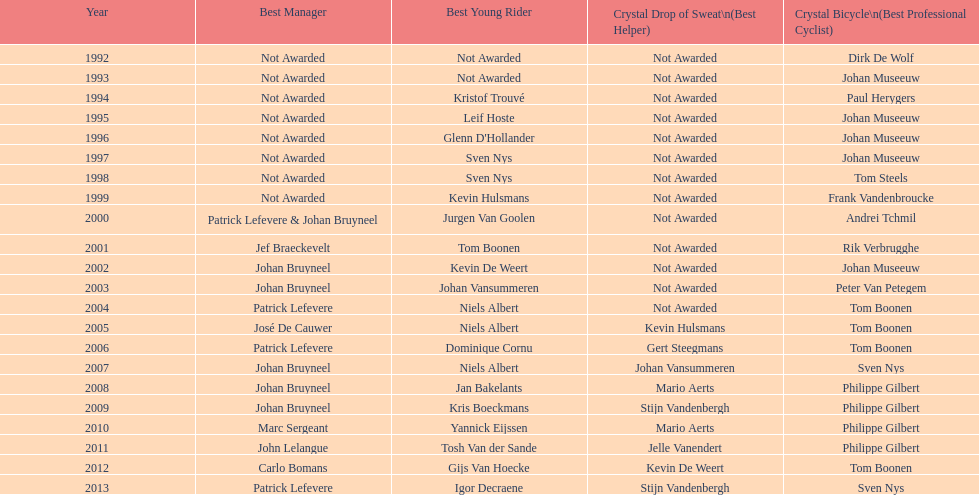What is the total number of times johan bryneel's name appears on all of these lists? 6. 